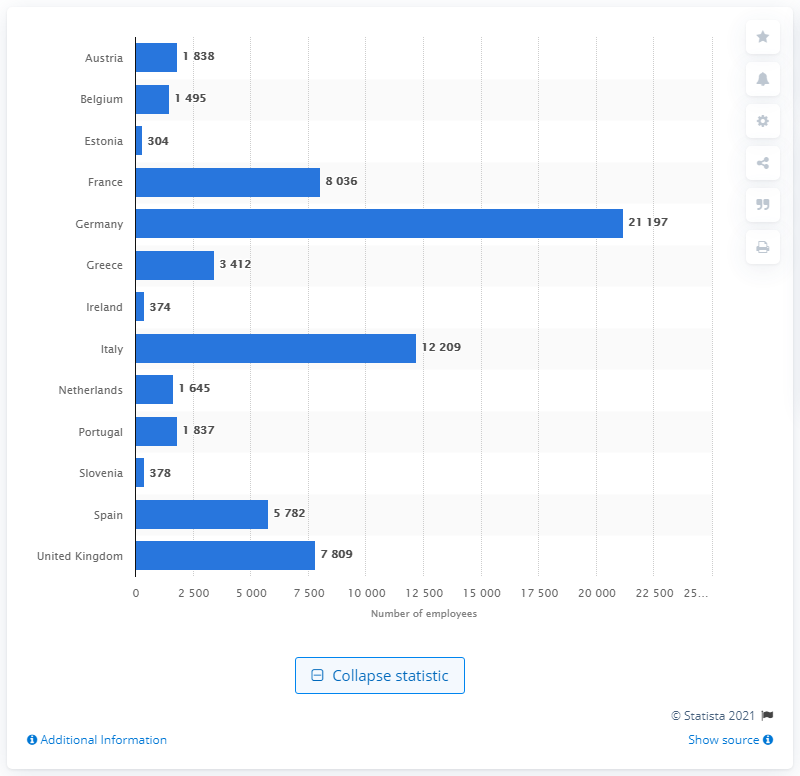Specify some key components in this picture. In 2018, there were 21,197 obstetricians and gynecologists employed in Germany. 